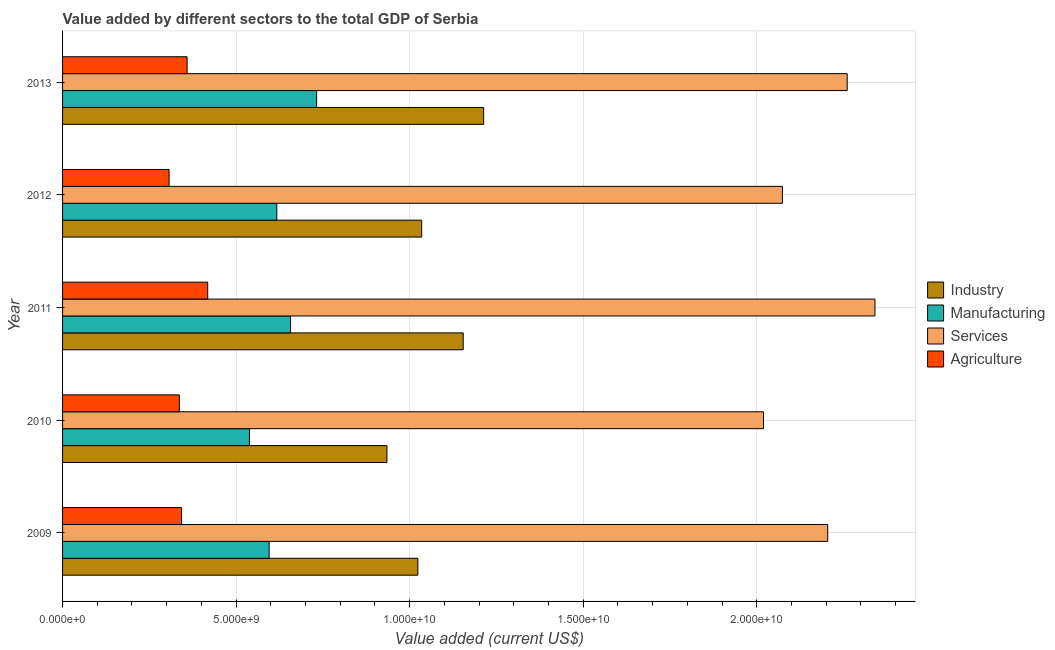How many different coloured bars are there?
Your answer should be very brief. 4. How many bars are there on the 5th tick from the top?
Your answer should be very brief. 4. What is the value added by manufacturing sector in 2011?
Offer a terse response. 6.57e+09. Across all years, what is the maximum value added by agricultural sector?
Your answer should be very brief. 4.18e+09. Across all years, what is the minimum value added by manufacturing sector?
Offer a very short reply. 5.38e+09. In which year was the value added by agricultural sector maximum?
Provide a short and direct response. 2011. In which year was the value added by manufacturing sector minimum?
Give a very brief answer. 2010. What is the total value added by industrial sector in the graph?
Ensure brevity in your answer.  5.36e+1. What is the difference between the value added by manufacturing sector in 2011 and that in 2013?
Make the answer very short. -7.51e+08. What is the difference between the value added by agricultural sector in 2012 and the value added by manufacturing sector in 2011?
Your response must be concise. -3.50e+09. What is the average value added by manufacturing sector per year?
Your answer should be very brief. 6.28e+09. In the year 2013, what is the difference between the value added by manufacturing sector and value added by services sector?
Keep it short and to the point. -1.53e+1. What is the ratio of the value added by manufacturing sector in 2010 to that in 2012?
Provide a succinct answer. 0.87. Is the difference between the value added by services sector in 2010 and 2012 greater than the difference between the value added by manufacturing sector in 2010 and 2012?
Keep it short and to the point. Yes. What is the difference between the highest and the second highest value added by industrial sector?
Give a very brief answer. 5.89e+08. What is the difference between the highest and the lowest value added by industrial sector?
Your answer should be compact. 2.79e+09. What does the 2nd bar from the top in 2012 represents?
Offer a terse response. Services. What does the 3rd bar from the bottom in 2009 represents?
Make the answer very short. Services. How many bars are there?
Give a very brief answer. 20. How many years are there in the graph?
Offer a very short reply. 5. What is the difference between two consecutive major ticks on the X-axis?
Provide a succinct answer. 5.00e+09. Are the values on the major ticks of X-axis written in scientific E-notation?
Provide a short and direct response. Yes. How many legend labels are there?
Your answer should be compact. 4. How are the legend labels stacked?
Provide a succinct answer. Vertical. What is the title of the graph?
Ensure brevity in your answer.  Value added by different sectors to the total GDP of Serbia. What is the label or title of the X-axis?
Offer a terse response. Value added (current US$). What is the Value added (current US$) of Industry in 2009?
Your answer should be compact. 1.02e+1. What is the Value added (current US$) of Manufacturing in 2009?
Offer a very short reply. 5.95e+09. What is the Value added (current US$) of Services in 2009?
Your answer should be very brief. 2.20e+1. What is the Value added (current US$) of Agriculture in 2009?
Your answer should be very brief. 3.43e+09. What is the Value added (current US$) of Industry in 2010?
Provide a succinct answer. 9.34e+09. What is the Value added (current US$) of Manufacturing in 2010?
Your answer should be very brief. 5.38e+09. What is the Value added (current US$) of Services in 2010?
Ensure brevity in your answer.  2.02e+1. What is the Value added (current US$) of Agriculture in 2010?
Your answer should be very brief. 3.36e+09. What is the Value added (current US$) in Industry in 2011?
Give a very brief answer. 1.15e+1. What is the Value added (current US$) in Manufacturing in 2011?
Offer a very short reply. 6.57e+09. What is the Value added (current US$) of Services in 2011?
Your answer should be very brief. 2.34e+1. What is the Value added (current US$) in Agriculture in 2011?
Your response must be concise. 4.18e+09. What is the Value added (current US$) in Industry in 2012?
Your answer should be compact. 1.03e+1. What is the Value added (current US$) in Manufacturing in 2012?
Keep it short and to the point. 6.17e+09. What is the Value added (current US$) of Services in 2012?
Keep it short and to the point. 2.07e+1. What is the Value added (current US$) of Agriculture in 2012?
Your answer should be very brief. 3.07e+09. What is the Value added (current US$) in Industry in 2013?
Your answer should be compact. 1.21e+1. What is the Value added (current US$) in Manufacturing in 2013?
Offer a very short reply. 7.32e+09. What is the Value added (current US$) of Services in 2013?
Provide a succinct answer. 2.26e+1. What is the Value added (current US$) of Agriculture in 2013?
Your answer should be compact. 3.59e+09. Across all years, what is the maximum Value added (current US$) of Industry?
Your answer should be compact. 1.21e+1. Across all years, what is the maximum Value added (current US$) in Manufacturing?
Ensure brevity in your answer.  7.32e+09. Across all years, what is the maximum Value added (current US$) of Services?
Your answer should be very brief. 2.34e+1. Across all years, what is the maximum Value added (current US$) of Agriculture?
Keep it short and to the point. 4.18e+09. Across all years, what is the minimum Value added (current US$) of Industry?
Ensure brevity in your answer.  9.34e+09. Across all years, what is the minimum Value added (current US$) in Manufacturing?
Offer a terse response. 5.38e+09. Across all years, what is the minimum Value added (current US$) of Services?
Your response must be concise. 2.02e+1. Across all years, what is the minimum Value added (current US$) in Agriculture?
Provide a short and direct response. 3.07e+09. What is the total Value added (current US$) in Industry in the graph?
Offer a terse response. 5.36e+1. What is the total Value added (current US$) of Manufacturing in the graph?
Keep it short and to the point. 3.14e+1. What is the total Value added (current US$) of Services in the graph?
Make the answer very short. 1.09e+11. What is the total Value added (current US$) in Agriculture in the graph?
Make the answer very short. 1.76e+1. What is the difference between the Value added (current US$) in Industry in 2009 and that in 2010?
Provide a short and direct response. 8.91e+08. What is the difference between the Value added (current US$) in Manufacturing in 2009 and that in 2010?
Your response must be concise. 5.67e+08. What is the difference between the Value added (current US$) of Services in 2009 and that in 2010?
Your response must be concise. 1.85e+09. What is the difference between the Value added (current US$) of Agriculture in 2009 and that in 2010?
Offer a terse response. 6.38e+07. What is the difference between the Value added (current US$) in Industry in 2009 and that in 2011?
Offer a very short reply. -1.31e+09. What is the difference between the Value added (current US$) of Manufacturing in 2009 and that in 2011?
Your response must be concise. -6.18e+08. What is the difference between the Value added (current US$) of Services in 2009 and that in 2011?
Your response must be concise. -1.36e+09. What is the difference between the Value added (current US$) in Agriculture in 2009 and that in 2011?
Keep it short and to the point. -7.53e+08. What is the difference between the Value added (current US$) of Industry in 2009 and that in 2012?
Provide a succinct answer. -1.11e+08. What is the difference between the Value added (current US$) in Manufacturing in 2009 and that in 2012?
Give a very brief answer. -2.21e+08. What is the difference between the Value added (current US$) in Services in 2009 and that in 2012?
Your response must be concise. 1.30e+09. What is the difference between the Value added (current US$) in Agriculture in 2009 and that in 2012?
Offer a terse response. 3.59e+08. What is the difference between the Value added (current US$) in Industry in 2009 and that in 2013?
Ensure brevity in your answer.  -1.90e+09. What is the difference between the Value added (current US$) in Manufacturing in 2009 and that in 2013?
Ensure brevity in your answer.  -1.37e+09. What is the difference between the Value added (current US$) of Services in 2009 and that in 2013?
Ensure brevity in your answer.  -5.61e+08. What is the difference between the Value added (current US$) in Agriculture in 2009 and that in 2013?
Your response must be concise. -1.59e+08. What is the difference between the Value added (current US$) in Industry in 2010 and that in 2011?
Your response must be concise. -2.20e+09. What is the difference between the Value added (current US$) in Manufacturing in 2010 and that in 2011?
Offer a terse response. -1.19e+09. What is the difference between the Value added (current US$) of Services in 2010 and that in 2011?
Keep it short and to the point. -3.21e+09. What is the difference between the Value added (current US$) of Agriculture in 2010 and that in 2011?
Offer a terse response. -8.17e+08. What is the difference between the Value added (current US$) in Industry in 2010 and that in 2012?
Make the answer very short. -1.00e+09. What is the difference between the Value added (current US$) in Manufacturing in 2010 and that in 2012?
Your response must be concise. -7.88e+08. What is the difference between the Value added (current US$) of Services in 2010 and that in 2012?
Give a very brief answer. -5.45e+08. What is the difference between the Value added (current US$) in Agriculture in 2010 and that in 2012?
Your answer should be compact. 2.95e+08. What is the difference between the Value added (current US$) of Industry in 2010 and that in 2013?
Offer a very short reply. -2.79e+09. What is the difference between the Value added (current US$) in Manufacturing in 2010 and that in 2013?
Give a very brief answer. -1.94e+09. What is the difference between the Value added (current US$) of Services in 2010 and that in 2013?
Ensure brevity in your answer.  -2.41e+09. What is the difference between the Value added (current US$) in Agriculture in 2010 and that in 2013?
Offer a very short reply. -2.23e+08. What is the difference between the Value added (current US$) of Industry in 2011 and that in 2012?
Your answer should be compact. 1.20e+09. What is the difference between the Value added (current US$) of Manufacturing in 2011 and that in 2012?
Your answer should be compact. 3.97e+08. What is the difference between the Value added (current US$) of Services in 2011 and that in 2012?
Give a very brief answer. 2.67e+09. What is the difference between the Value added (current US$) in Agriculture in 2011 and that in 2012?
Provide a succinct answer. 1.11e+09. What is the difference between the Value added (current US$) of Industry in 2011 and that in 2013?
Your response must be concise. -5.89e+08. What is the difference between the Value added (current US$) in Manufacturing in 2011 and that in 2013?
Provide a succinct answer. -7.51e+08. What is the difference between the Value added (current US$) in Services in 2011 and that in 2013?
Provide a short and direct response. 8.00e+08. What is the difference between the Value added (current US$) of Agriculture in 2011 and that in 2013?
Offer a terse response. 5.93e+08. What is the difference between the Value added (current US$) in Industry in 2012 and that in 2013?
Provide a succinct answer. -1.79e+09. What is the difference between the Value added (current US$) in Manufacturing in 2012 and that in 2013?
Ensure brevity in your answer.  -1.15e+09. What is the difference between the Value added (current US$) of Services in 2012 and that in 2013?
Your response must be concise. -1.87e+09. What is the difference between the Value added (current US$) of Agriculture in 2012 and that in 2013?
Provide a succinct answer. -5.19e+08. What is the difference between the Value added (current US$) in Industry in 2009 and the Value added (current US$) in Manufacturing in 2010?
Keep it short and to the point. 4.85e+09. What is the difference between the Value added (current US$) of Industry in 2009 and the Value added (current US$) of Services in 2010?
Offer a terse response. -9.96e+09. What is the difference between the Value added (current US$) of Industry in 2009 and the Value added (current US$) of Agriculture in 2010?
Your response must be concise. 6.87e+09. What is the difference between the Value added (current US$) in Manufacturing in 2009 and the Value added (current US$) in Services in 2010?
Your response must be concise. -1.42e+1. What is the difference between the Value added (current US$) in Manufacturing in 2009 and the Value added (current US$) in Agriculture in 2010?
Your answer should be compact. 2.59e+09. What is the difference between the Value added (current US$) in Services in 2009 and the Value added (current US$) in Agriculture in 2010?
Give a very brief answer. 1.87e+1. What is the difference between the Value added (current US$) in Industry in 2009 and the Value added (current US$) in Manufacturing in 2011?
Give a very brief answer. 3.67e+09. What is the difference between the Value added (current US$) of Industry in 2009 and the Value added (current US$) of Services in 2011?
Give a very brief answer. -1.32e+1. What is the difference between the Value added (current US$) in Industry in 2009 and the Value added (current US$) in Agriculture in 2011?
Provide a succinct answer. 6.05e+09. What is the difference between the Value added (current US$) of Manufacturing in 2009 and the Value added (current US$) of Services in 2011?
Make the answer very short. -1.75e+1. What is the difference between the Value added (current US$) of Manufacturing in 2009 and the Value added (current US$) of Agriculture in 2011?
Provide a succinct answer. 1.77e+09. What is the difference between the Value added (current US$) of Services in 2009 and the Value added (current US$) of Agriculture in 2011?
Offer a very short reply. 1.79e+1. What is the difference between the Value added (current US$) of Industry in 2009 and the Value added (current US$) of Manufacturing in 2012?
Offer a very short reply. 4.06e+09. What is the difference between the Value added (current US$) in Industry in 2009 and the Value added (current US$) in Services in 2012?
Make the answer very short. -1.05e+1. What is the difference between the Value added (current US$) in Industry in 2009 and the Value added (current US$) in Agriculture in 2012?
Ensure brevity in your answer.  7.17e+09. What is the difference between the Value added (current US$) of Manufacturing in 2009 and the Value added (current US$) of Services in 2012?
Offer a terse response. -1.48e+1. What is the difference between the Value added (current US$) in Manufacturing in 2009 and the Value added (current US$) in Agriculture in 2012?
Provide a succinct answer. 2.88e+09. What is the difference between the Value added (current US$) in Services in 2009 and the Value added (current US$) in Agriculture in 2012?
Ensure brevity in your answer.  1.90e+1. What is the difference between the Value added (current US$) of Industry in 2009 and the Value added (current US$) of Manufacturing in 2013?
Ensure brevity in your answer.  2.92e+09. What is the difference between the Value added (current US$) in Industry in 2009 and the Value added (current US$) in Services in 2013?
Provide a short and direct response. -1.24e+1. What is the difference between the Value added (current US$) of Industry in 2009 and the Value added (current US$) of Agriculture in 2013?
Your response must be concise. 6.65e+09. What is the difference between the Value added (current US$) of Manufacturing in 2009 and the Value added (current US$) of Services in 2013?
Your response must be concise. -1.67e+1. What is the difference between the Value added (current US$) of Manufacturing in 2009 and the Value added (current US$) of Agriculture in 2013?
Your answer should be very brief. 2.36e+09. What is the difference between the Value added (current US$) of Services in 2009 and the Value added (current US$) of Agriculture in 2013?
Ensure brevity in your answer.  1.85e+1. What is the difference between the Value added (current US$) in Industry in 2010 and the Value added (current US$) in Manufacturing in 2011?
Give a very brief answer. 2.78e+09. What is the difference between the Value added (current US$) in Industry in 2010 and the Value added (current US$) in Services in 2011?
Offer a terse response. -1.41e+1. What is the difference between the Value added (current US$) in Industry in 2010 and the Value added (current US$) in Agriculture in 2011?
Make the answer very short. 5.16e+09. What is the difference between the Value added (current US$) in Manufacturing in 2010 and the Value added (current US$) in Services in 2011?
Provide a succinct answer. -1.80e+1. What is the difference between the Value added (current US$) of Manufacturing in 2010 and the Value added (current US$) of Agriculture in 2011?
Your answer should be very brief. 1.20e+09. What is the difference between the Value added (current US$) of Services in 2010 and the Value added (current US$) of Agriculture in 2011?
Make the answer very short. 1.60e+1. What is the difference between the Value added (current US$) in Industry in 2010 and the Value added (current US$) in Manufacturing in 2012?
Keep it short and to the point. 3.17e+09. What is the difference between the Value added (current US$) in Industry in 2010 and the Value added (current US$) in Services in 2012?
Your answer should be very brief. -1.14e+1. What is the difference between the Value added (current US$) in Industry in 2010 and the Value added (current US$) in Agriculture in 2012?
Give a very brief answer. 6.27e+09. What is the difference between the Value added (current US$) in Manufacturing in 2010 and the Value added (current US$) in Services in 2012?
Offer a very short reply. -1.54e+1. What is the difference between the Value added (current US$) in Manufacturing in 2010 and the Value added (current US$) in Agriculture in 2012?
Ensure brevity in your answer.  2.31e+09. What is the difference between the Value added (current US$) in Services in 2010 and the Value added (current US$) in Agriculture in 2012?
Make the answer very short. 1.71e+1. What is the difference between the Value added (current US$) of Industry in 2010 and the Value added (current US$) of Manufacturing in 2013?
Offer a very short reply. 2.02e+09. What is the difference between the Value added (current US$) in Industry in 2010 and the Value added (current US$) in Services in 2013?
Provide a succinct answer. -1.33e+1. What is the difference between the Value added (current US$) in Industry in 2010 and the Value added (current US$) in Agriculture in 2013?
Your response must be concise. 5.76e+09. What is the difference between the Value added (current US$) in Manufacturing in 2010 and the Value added (current US$) in Services in 2013?
Offer a terse response. -1.72e+1. What is the difference between the Value added (current US$) in Manufacturing in 2010 and the Value added (current US$) in Agriculture in 2013?
Provide a short and direct response. 1.80e+09. What is the difference between the Value added (current US$) in Services in 2010 and the Value added (current US$) in Agriculture in 2013?
Give a very brief answer. 1.66e+1. What is the difference between the Value added (current US$) in Industry in 2011 and the Value added (current US$) in Manufacturing in 2012?
Ensure brevity in your answer.  5.37e+09. What is the difference between the Value added (current US$) in Industry in 2011 and the Value added (current US$) in Services in 2012?
Your answer should be compact. -9.20e+09. What is the difference between the Value added (current US$) in Industry in 2011 and the Value added (current US$) in Agriculture in 2012?
Offer a very short reply. 8.47e+09. What is the difference between the Value added (current US$) of Manufacturing in 2011 and the Value added (current US$) of Services in 2012?
Your answer should be compact. -1.42e+1. What is the difference between the Value added (current US$) of Manufacturing in 2011 and the Value added (current US$) of Agriculture in 2012?
Your answer should be very brief. 3.50e+09. What is the difference between the Value added (current US$) of Services in 2011 and the Value added (current US$) of Agriculture in 2012?
Provide a succinct answer. 2.03e+1. What is the difference between the Value added (current US$) of Industry in 2011 and the Value added (current US$) of Manufacturing in 2013?
Offer a terse response. 4.22e+09. What is the difference between the Value added (current US$) of Industry in 2011 and the Value added (current US$) of Services in 2013?
Offer a very short reply. -1.11e+1. What is the difference between the Value added (current US$) of Industry in 2011 and the Value added (current US$) of Agriculture in 2013?
Ensure brevity in your answer.  7.95e+09. What is the difference between the Value added (current US$) of Manufacturing in 2011 and the Value added (current US$) of Services in 2013?
Provide a succinct answer. -1.60e+1. What is the difference between the Value added (current US$) in Manufacturing in 2011 and the Value added (current US$) in Agriculture in 2013?
Offer a very short reply. 2.98e+09. What is the difference between the Value added (current US$) in Services in 2011 and the Value added (current US$) in Agriculture in 2013?
Provide a succinct answer. 1.98e+1. What is the difference between the Value added (current US$) in Industry in 2012 and the Value added (current US$) in Manufacturing in 2013?
Ensure brevity in your answer.  3.03e+09. What is the difference between the Value added (current US$) of Industry in 2012 and the Value added (current US$) of Services in 2013?
Provide a short and direct response. -1.23e+1. What is the difference between the Value added (current US$) in Industry in 2012 and the Value added (current US$) in Agriculture in 2013?
Provide a short and direct response. 6.76e+09. What is the difference between the Value added (current US$) in Manufacturing in 2012 and the Value added (current US$) in Services in 2013?
Keep it short and to the point. -1.64e+1. What is the difference between the Value added (current US$) in Manufacturing in 2012 and the Value added (current US$) in Agriculture in 2013?
Keep it short and to the point. 2.58e+09. What is the difference between the Value added (current US$) of Services in 2012 and the Value added (current US$) of Agriculture in 2013?
Your answer should be compact. 1.72e+1. What is the average Value added (current US$) in Industry per year?
Make the answer very short. 1.07e+1. What is the average Value added (current US$) in Manufacturing per year?
Provide a short and direct response. 6.28e+09. What is the average Value added (current US$) in Services per year?
Your answer should be very brief. 2.18e+1. What is the average Value added (current US$) in Agriculture per year?
Keep it short and to the point. 3.53e+09. In the year 2009, what is the difference between the Value added (current US$) of Industry and Value added (current US$) of Manufacturing?
Your answer should be compact. 4.28e+09. In the year 2009, what is the difference between the Value added (current US$) of Industry and Value added (current US$) of Services?
Your response must be concise. -1.18e+1. In the year 2009, what is the difference between the Value added (current US$) in Industry and Value added (current US$) in Agriculture?
Keep it short and to the point. 6.81e+09. In the year 2009, what is the difference between the Value added (current US$) in Manufacturing and Value added (current US$) in Services?
Your answer should be compact. -1.61e+1. In the year 2009, what is the difference between the Value added (current US$) of Manufacturing and Value added (current US$) of Agriculture?
Your response must be concise. 2.52e+09. In the year 2009, what is the difference between the Value added (current US$) of Services and Value added (current US$) of Agriculture?
Keep it short and to the point. 1.86e+1. In the year 2010, what is the difference between the Value added (current US$) of Industry and Value added (current US$) of Manufacturing?
Your answer should be very brief. 3.96e+09. In the year 2010, what is the difference between the Value added (current US$) of Industry and Value added (current US$) of Services?
Give a very brief answer. -1.08e+1. In the year 2010, what is the difference between the Value added (current US$) of Industry and Value added (current US$) of Agriculture?
Your response must be concise. 5.98e+09. In the year 2010, what is the difference between the Value added (current US$) of Manufacturing and Value added (current US$) of Services?
Offer a terse response. -1.48e+1. In the year 2010, what is the difference between the Value added (current US$) of Manufacturing and Value added (current US$) of Agriculture?
Provide a short and direct response. 2.02e+09. In the year 2010, what is the difference between the Value added (current US$) in Services and Value added (current US$) in Agriculture?
Ensure brevity in your answer.  1.68e+1. In the year 2011, what is the difference between the Value added (current US$) of Industry and Value added (current US$) of Manufacturing?
Your answer should be very brief. 4.97e+09. In the year 2011, what is the difference between the Value added (current US$) in Industry and Value added (current US$) in Services?
Ensure brevity in your answer.  -1.19e+1. In the year 2011, what is the difference between the Value added (current US$) of Industry and Value added (current US$) of Agriculture?
Provide a succinct answer. 7.36e+09. In the year 2011, what is the difference between the Value added (current US$) in Manufacturing and Value added (current US$) in Services?
Keep it short and to the point. -1.68e+1. In the year 2011, what is the difference between the Value added (current US$) in Manufacturing and Value added (current US$) in Agriculture?
Provide a short and direct response. 2.39e+09. In the year 2011, what is the difference between the Value added (current US$) of Services and Value added (current US$) of Agriculture?
Give a very brief answer. 1.92e+1. In the year 2012, what is the difference between the Value added (current US$) in Industry and Value added (current US$) in Manufacturing?
Your answer should be compact. 4.17e+09. In the year 2012, what is the difference between the Value added (current US$) in Industry and Value added (current US$) in Services?
Your answer should be compact. -1.04e+1. In the year 2012, what is the difference between the Value added (current US$) in Industry and Value added (current US$) in Agriculture?
Your answer should be very brief. 7.28e+09. In the year 2012, what is the difference between the Value added (current US$) of Manufacturing and Value added (current US$) of Services?
Your response must be concise. -1.46e+1. In the year 2012, what is the difference between the Value added (current US$) of Manufacturing and Value added (current US$) of Agriculture?
Provide a short and direct response. 3.10e+09. In the year 2012, what is the difference between the Value added (current US$) of Services and Value added (current US$) of Agriculture?
Give a very brief answer. 1.77e+1. In the year 2013, what is the difference between the Value added (current US$) in Industry and Value added (current US$) in Manufacturing?
Your response must be concise. 4.81e+09. In the year 2013, what is the difference between the Value added (current US$) of Industry and Value added (current US$) of Services?
Provide a short and direct response. -1.05e+1. In the year 2013, what is the difference between the Value added (current US$) in Industry and Value added (current US$) in Agriculture?
Your answer should be very brief. 8.54e+09. In the year 2013, what is the difference between the Value added (current US$) in Manufacturing and Value added (current US$) in Services?
Keep it short and to the point. -1.53e+1. In the year 2013, what is the difference between the Value added (current US$) of Manufacturing and Value added (current US$) of Agriculture?
Provide a short and direct response. 3.73e+09. In the year 2013, what is the difference between the Value added (current US$) of Services and Value added (current US$) of Agriculture?
Your response must be concise. 1.90e+1. What is the ratio of the Value added (current US$) of Industry in 2009 to that in 2010?
Your answer should be very brief. 1.1. What is the ratio of the Value added (current US$) in Manufacturing in 2009 to that in 2010?
Ensure brevity in your answer.  1.11. What is the ratio of the Value added (current US$) in Services in 2009 to that in 2010?
Give a very brief answer. 1.09. What is the ratio of the Value added (current US$) in Industry in 2009 to that in 2011?
Provide a short and direct response. 0.89. What is the ratio of the Value added (current US$) in Manufacturing in 2009 to that in 2011?
Give a very brief answer. 0.91. What is the ratio of the Value added (current US$) of Services in 2009 to that in 2011?
Offer a terse response. 0.94. What is the ratio of the Value added (current US$) of Agriculture in 2009 to that in 2011?
Make the answer very short. 0.82. What is the ratio of the Value added (current US$) of Industry in 2009 to that in 2012?
Keep it short and to the point. 0.99. What is the ratio of the Value added (current US$) in Manufacturing in 2009 to that in 2012?
Your answer should be compact. 0.96. What is the ratio of the Value added (current US$) of Services in 2009 to that in 2012?
Provide a succinct answer. 1.06. What is the ratio of the Value added (current US$) of Agriculture in 2009 to that in 2012?
Make the answer very short. 1.12. What is the ratio of the Value added (current US$) of Industry in 2009 to that in 2013?
Give a very brief answer. 0.84. What is the ratio of the Value added (current US$) in Manufacturing in 2009 to that in 2013?
Offer a terse response. 0.81. What is the ratio of the Value added (current US$) of Services in 2009 to that in 2013?
Keep it short and to the point. 0.98. What is the ratio of the Value added (current US$) of Agriculture in 2009 to that in 2013?
Your answer should be compact. 0.96. What is the ratio of the Value added (current US$) of Industry in 2010 to that in 2011?
Offer a terse response. 0.81. What is the ratio of the Value added (current US$) of Manufacturing in 2010 to that in 2011?
Provide a short and direct response. 0.82. What is the ratio of the Value added (current US$) in Services in 2010 to that in 2011?
Offer a terse response. 0.86. What is the ratio of the Value added (current US$) in Agriculture in 2010 to that in 2011?
Ensure brevity in your answer.  0.8. What is the ratio of the Value added (current US$) in Industry in 2010 to that in 2012?
Offer a terse response. 0.9. What is the ratio of the Value added (current US$) in Manufacturing in 2010 to that in 2012?
Your response must be concise. 0.87. What is the ratio of the Value added (current US$) in Services in 2010 to that in 2012?
Make the answer very short. 0.97. What is the ratio of the Value added (current US$) of Agriculture in 2010 to that in 2012?
Your response must be concise. 1.1. What is the ratio of the Value added (current US$) of Industry in 2010 to that in 2013?
Your answer should be very brief. 0.77. What is the ratio of the Value added (current US$) in Manufacturing in 2010 to that in 2013?
Give a very brief answer. 0.74. What is the ratio of the Value added (current US$) of Services in 2010 to that in 2013?
Offer a very short reply. 0.89. What is the ratio of the Value added (current US$) of Agriculture in 2010 to that in 2013?
Provide a short and direct response. 0.94. What is the ratio of the Value added (current US$) in Industry in 2011 to that in 2012?
Your answer should be compact. 1.12. What is the ratio of the Value added (current US$) of Manufacturing in 2011 to that in 2012?
Your answer should be compact. 1.06. What is the ratio of the Value added (current US$) in Services in 2011 to that in 2012?
Provide a succinct answer. 1.13. What is the ratio of the Value added (current US$) of Agriculture in 2011 to that in 2012?
Your answer should be compact. 1.36. What is the ratio of the Value added (current US$) of Industry in 2011 to that in 2013?
Ensure brevity in your answer.  0.95. What is the ratio of the Value added (current US$) in Manufacturing in 2011 to that in 2013?
Keep it short and to the point. 0.9. What is the ratio of the Value added (current US$) of Services in 2011 to that in 2013?
Your answer should be compact. 1.04. What is the ratio of the Value added (current US$) in Agriculture in 2011 to that in 2013?
Ensure brevity in your answer.  1.17. What is the ratio of the Value added (current US$) in Industry in 2012 to that in 2013?
Your answer should be compact. 0.85. What is the ratio of the Value added (current US$) in Manufacturing in 2012 to that in 2013?
Keep it short and to the point. 0.84. What is the ratio of the Value added (current US$) of Services in 2012 to that in 2013?
Your answer should be very brief. 0.92. What is the ratio of the Value added (current US$) in Agriculture in 2012 to that in 2013?
Offer a very short reply. 0.86. What is the difference between the highest and the second highest Value added (current US$) of Industry?
Offer a very short reply. 5.89e+08. What is the difference between the highest and the second highest Value added (current US$) of Manufacturing?
Your answer should be compact. 7.51e+08. What is the difference between the highest and the second highest Value added (current US$) of Services?
Offer a very short reply. 8.00e+08. What is the difference between the highest and the second highest Value added (current US$) of Agriculture?
Ensure brevity in your answer.  5.93e+08. What is the difference between the highest and the lowest Value added (current US$) of Industry?
Your answer should be very brief. 2.79e+09. What is the difference between the highest and the lowest Value added (current US$) in Manufacturing?
Your answer should be very brief. 1.94e+09. What is the difference between the highest and the lowest Value added (current US$) of Services?
Make the answer very short. 3.21e+09. What is the difference between the highest and the lowest Value added (current US$) of Agriculture?
Provide a short and direct response. 1.11e+09. 